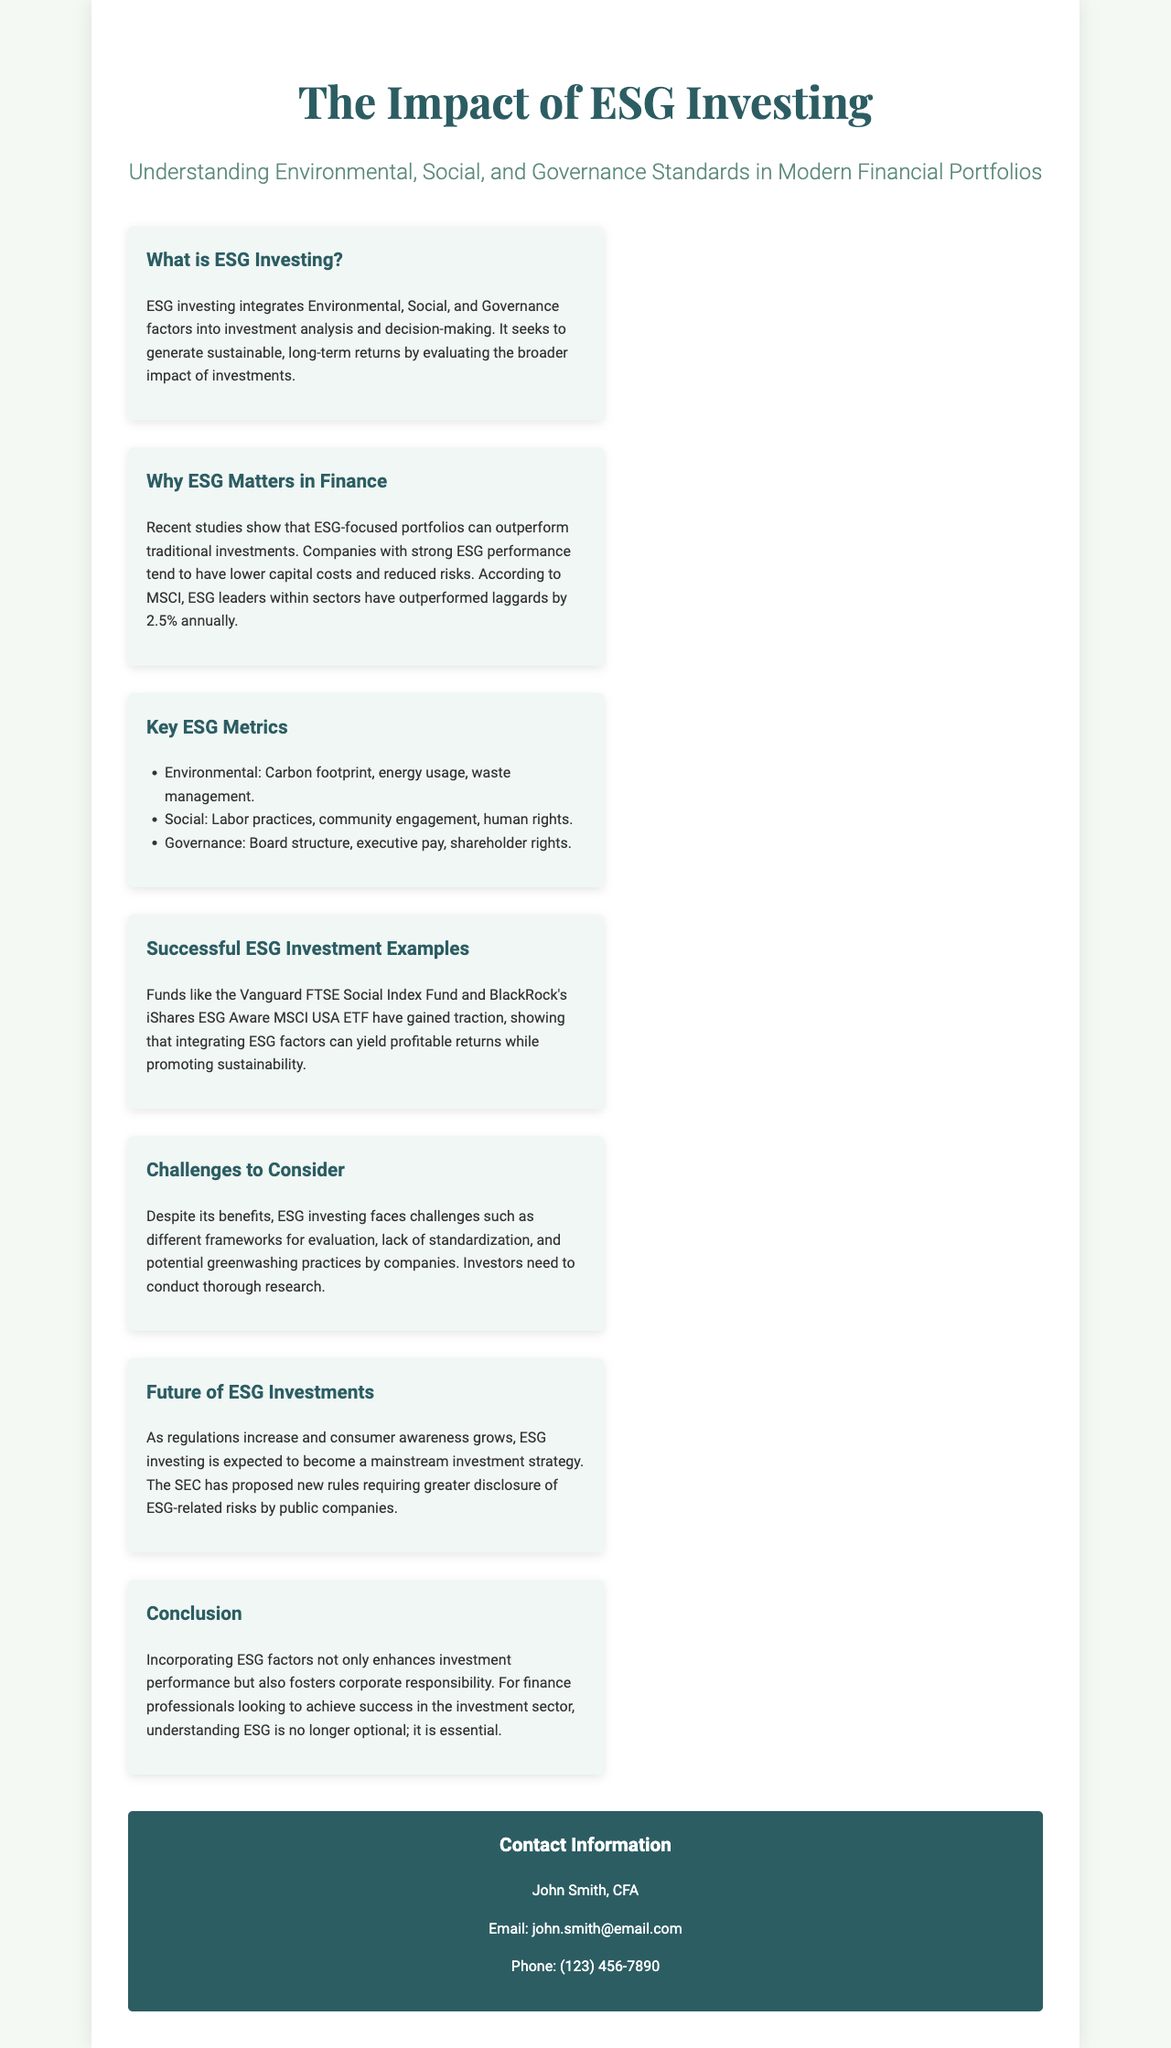What is ESG investing? ESG investing integrates Environmental, Social, and Governance factors into investment analysis and decision-making.
Answer: Integrates ESG factors Why is ESG important in finance? Recent studies show that ESG-focused portfolios can outperform traditional investments, companies with strong ESG performance tend to have lower capital costs and reduced risks.
Answer: Outperform traditional investments What are the key ESG metrics? The document lists Environmental, Social, and Governance factors as key metrics.
Answer: Environmental, Social, Governance What examples of successful ESG investments are mentioned? The brochure mentions the Vanguard FTSE Social Index Fund and BlackRock's iShares ESG Aware MSCI USA ETF as successful ESG investment examples.
Answer: Vanguard FTSE Social Index Fund, BlackRock's iShares ESG Aware MSCI USA ETF What challenges does ESG investing face? The brochure states challenges include different frameworks for evaluation, lack of standardization, and potential greenwashing practices.
Answer: Different frameworks, lack of standardization, greenwashing What is expected for the future of ESG investments? The SEC has proposed new rules requiring greater disclosure of ESG-related risks by public companies.
Answer: Greater disclosure of ESG-related risks What is the overall conclusion regarding ESG factors? Incorporating ESG factors enhances investment performance and fosters corporate responsibility for finance professionals.
Answer: Enhances investment performance, fosters corporate responsibility 